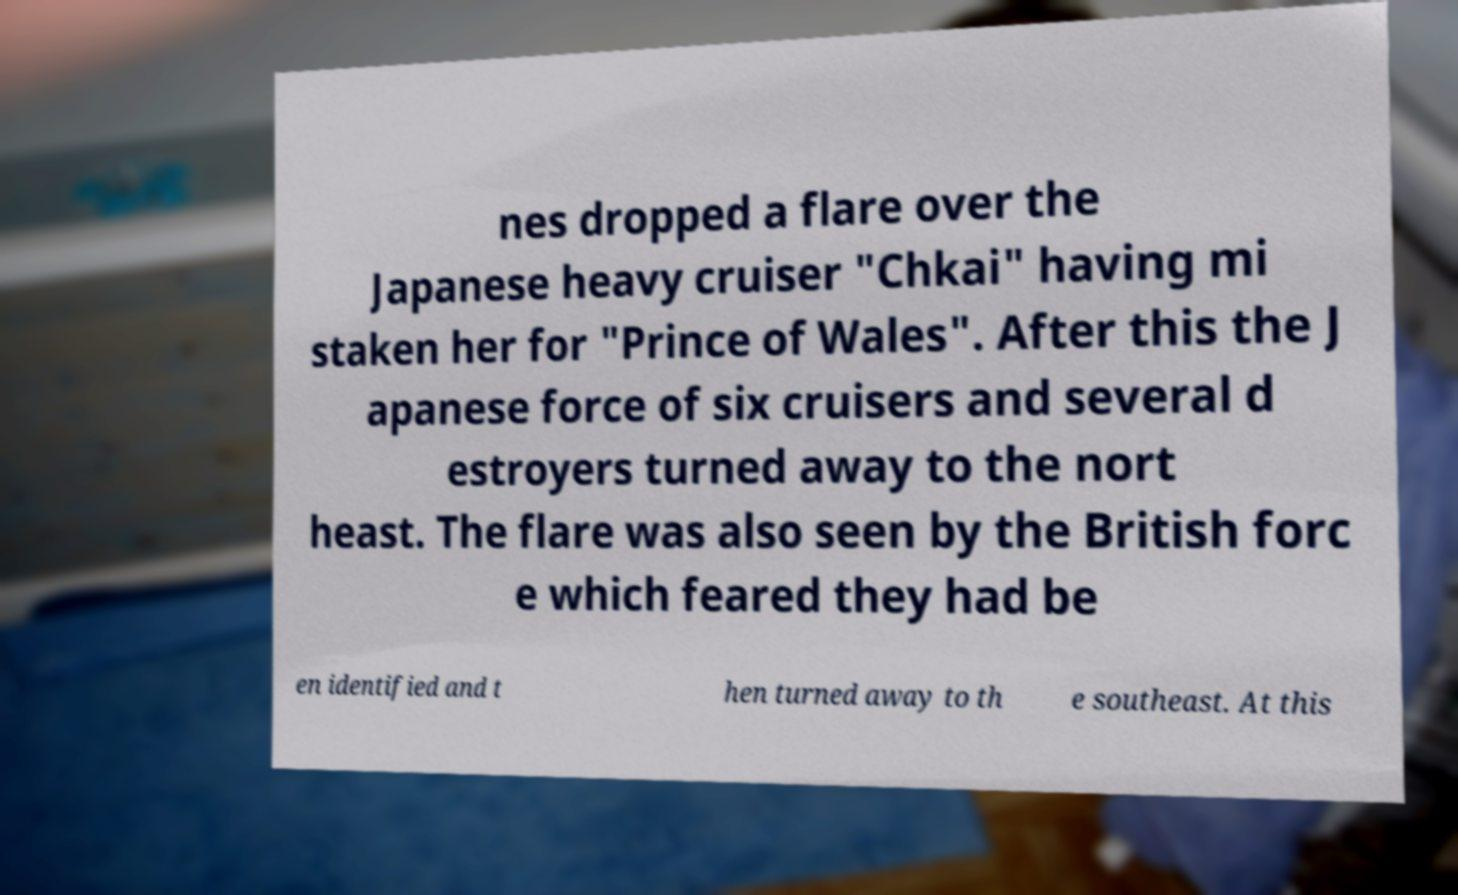Please identify and transcribe the text found in this image. nes dropped a flare over the Japanese heavy cruiser "Chkai" having mi staken her for "Prince of Wales". After this the J apanese force of six cruisers and several d estroyers turned away to the nort heast. The flare was also seen by the British forc e which feared they had be en identified and t hen turned away to th e southeast. At this 